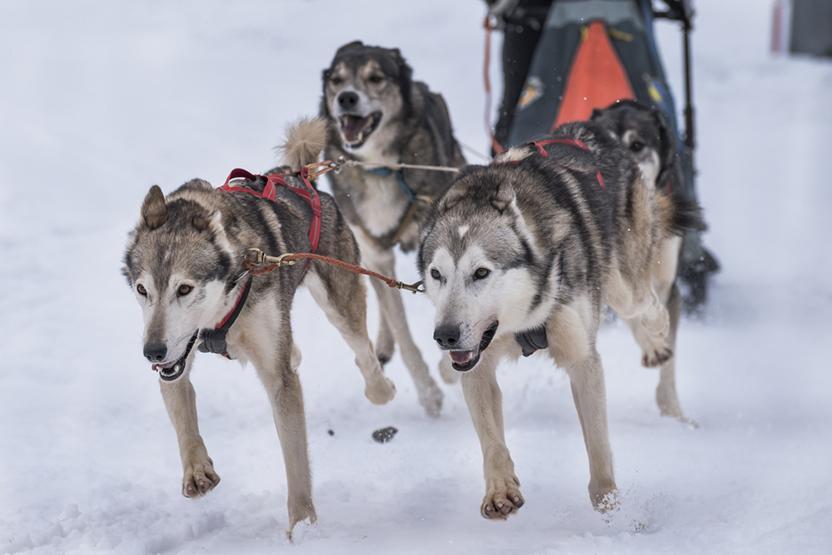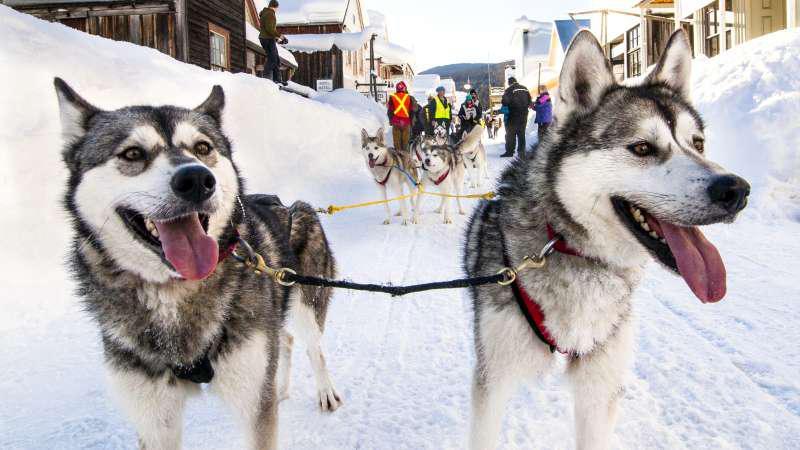The first image is the image on the left, the second image is the image on the right. Given the left and right images, does the statement "The right image shows a dog team racing forward and toward the right, and the left image shows a dog team that is not moving." hold true? Answer yes or no. No. 